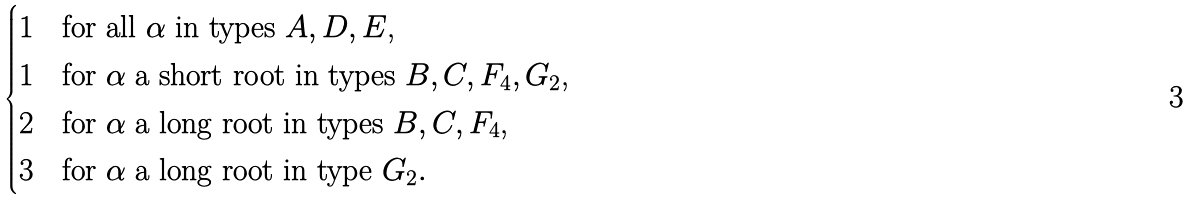<formula> <loc_0><loc_0><loc_500><loc_500>\begin{cases} 1 & \text {for all $\alpha$ in types $A, D, E$,} \\ 1 & \text {for $\alpha$ a short root in types $B, C, F_{4}, G_{2}$,} \\ 2 & \text {for $\alpha$ a long root in types $B, C, F_{4}$,} \\ 3 & \text {for $\alpha$ a long root in type $G_{2}$} . \end{cases}</formula> 